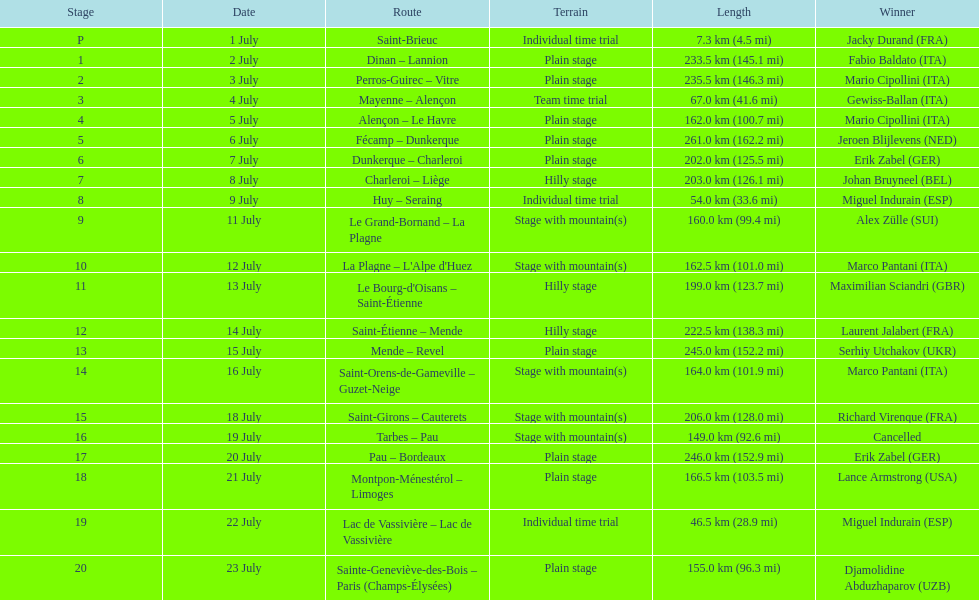How much more extended is the 20th tour de france stage compared to the 19th? 108.5 km. 